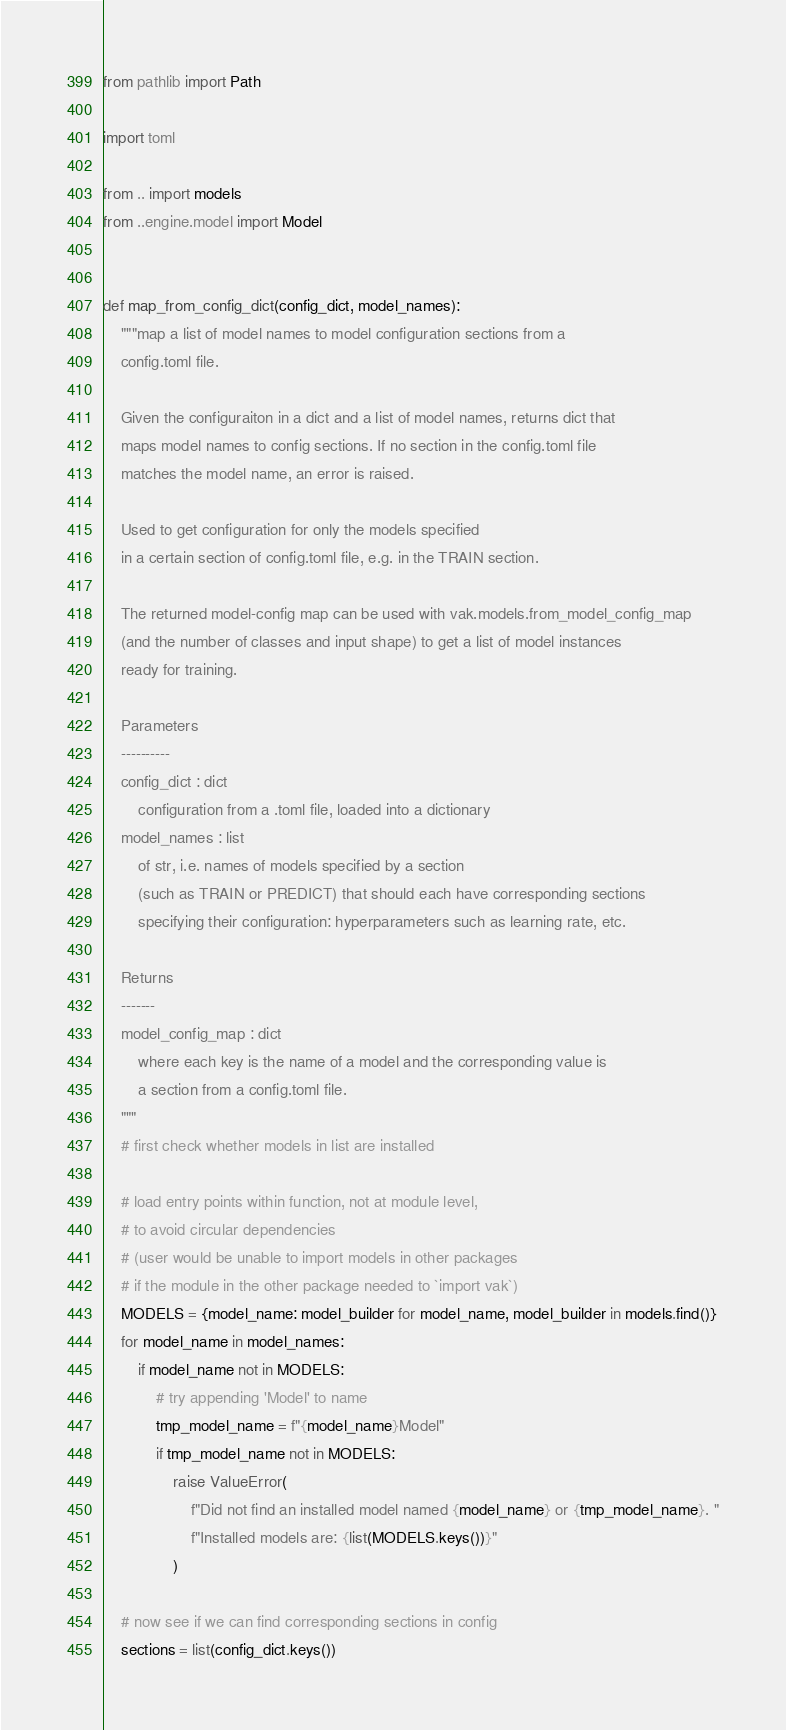Convert code to text. <code><loc_0><loc_0><loc_500><loc_500><_Python_>from pathlib import Path

import toml

from .. import models
from ..engine.model import Model


def map_from_config_dict(config_dict, model_names):
    """map a list of model names to model configuration sections from a
    config.toml file.

    Given the configuraiton in a dict and a list of model names, returns dict that
    maps model names to config sections. If no section in the config.toml file
    matches the model name, an error is raised.

    Used to get configuration for only the models specified
    in a certain section of config.toml file, e.g. in the TRAIN section.

    The returned model-config map can be used with vak.models.from_model_config_map
    (and the number of classes and input shape) to get a list of model instances
    ready for training.

    Parameters
    ----------
    config_dict : dict
        configuration from a .toml file, loaded into a dictionary
    model_names : list
        of str, i.e. names of models specified by a section
        (such as TRAIN or PREDICT) that should each have corresponding sections
        specifying their configuration: hyperparameters such as learning rate, etc.

    Returns
    -------
    model_config_map : dict
        where each key is the name of a model and the corresponding value is
        a section from a config.toml file.
    """
    # first check whether models in list are installed

    # load entry points within function, not at module level,
    # to avoid circular dependencies
    # (user would be unable to import models in other packages
    # if the module in the other package needed to `import vak`)
    MODELS = {model_name: model_builder for model_name, model_builder in models.find()}
    for model_name in model_names:
        if model_name not in MODELS:
            # try appending 'Model' to name
            tmp_model_name = f"{model_name}Model"
            if tmp_model_name not in MODELS:
                raise ValueError(
                    f"Did not find an installed model named {model_name} or {tmp_model_name}. "
                    f"Installed models are: {list(MODELS.keys())}"
                )

    # now see if we can find corresponding sections in config
    sections = list(config_dict.keys())</code> 